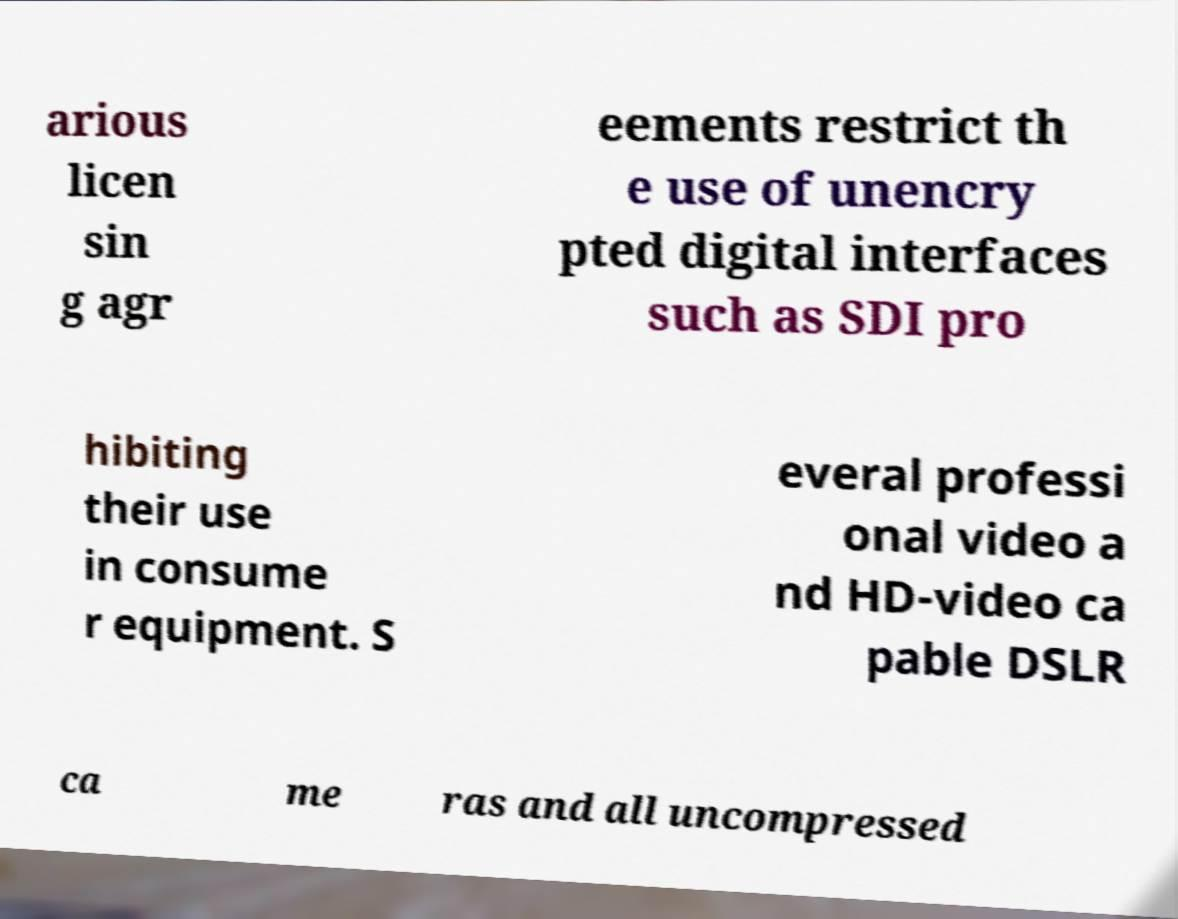Please identify and transcribe the text found in this image. arious licen sin g agr eements restrict th e use of unencry pted digital interfaces such as SDI pro hibiting their use in consume r equipment. S everal professi onal video a nd HD-video ca pable DSLR ca me ras and all uncompressed 